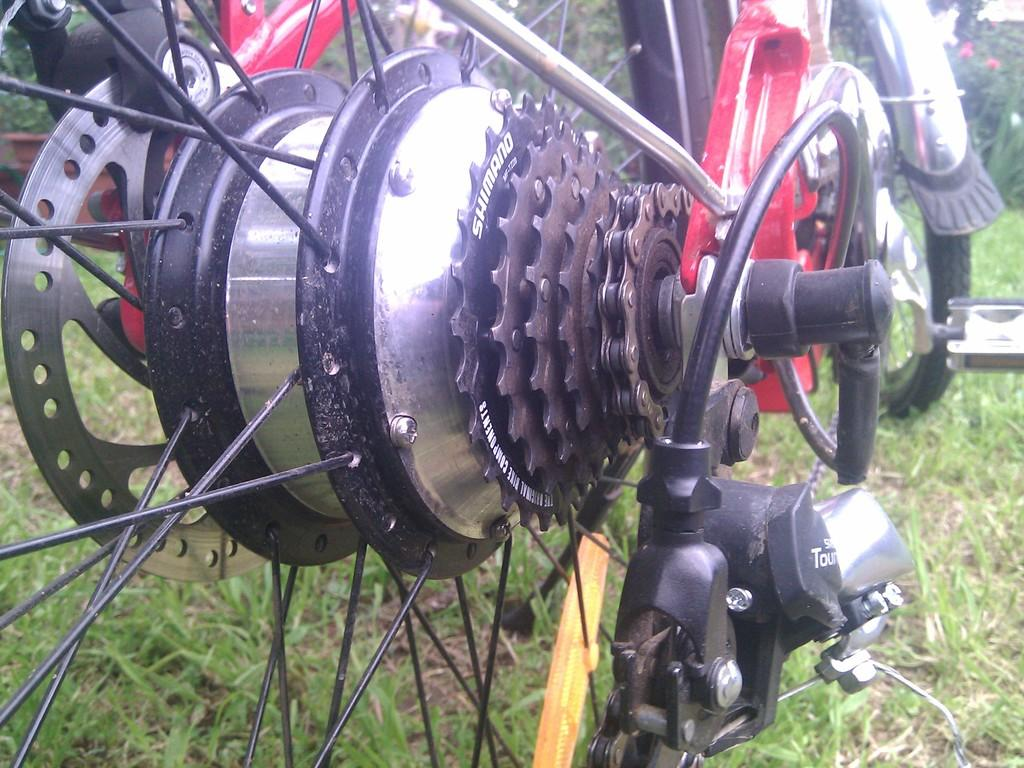What type of bicycle is in the image? There is a bicycle with gears in the image. What is the surface beneath the bicycle? The bicycle is on a grass surface. What objects are in front of the bicycle? There are flower pots in front of the bicycle. What can be seen in the background of the image? There are trees visible in the image. Who is the stranger standing on the roof in the image? There is no stranger or roof present in the image. 